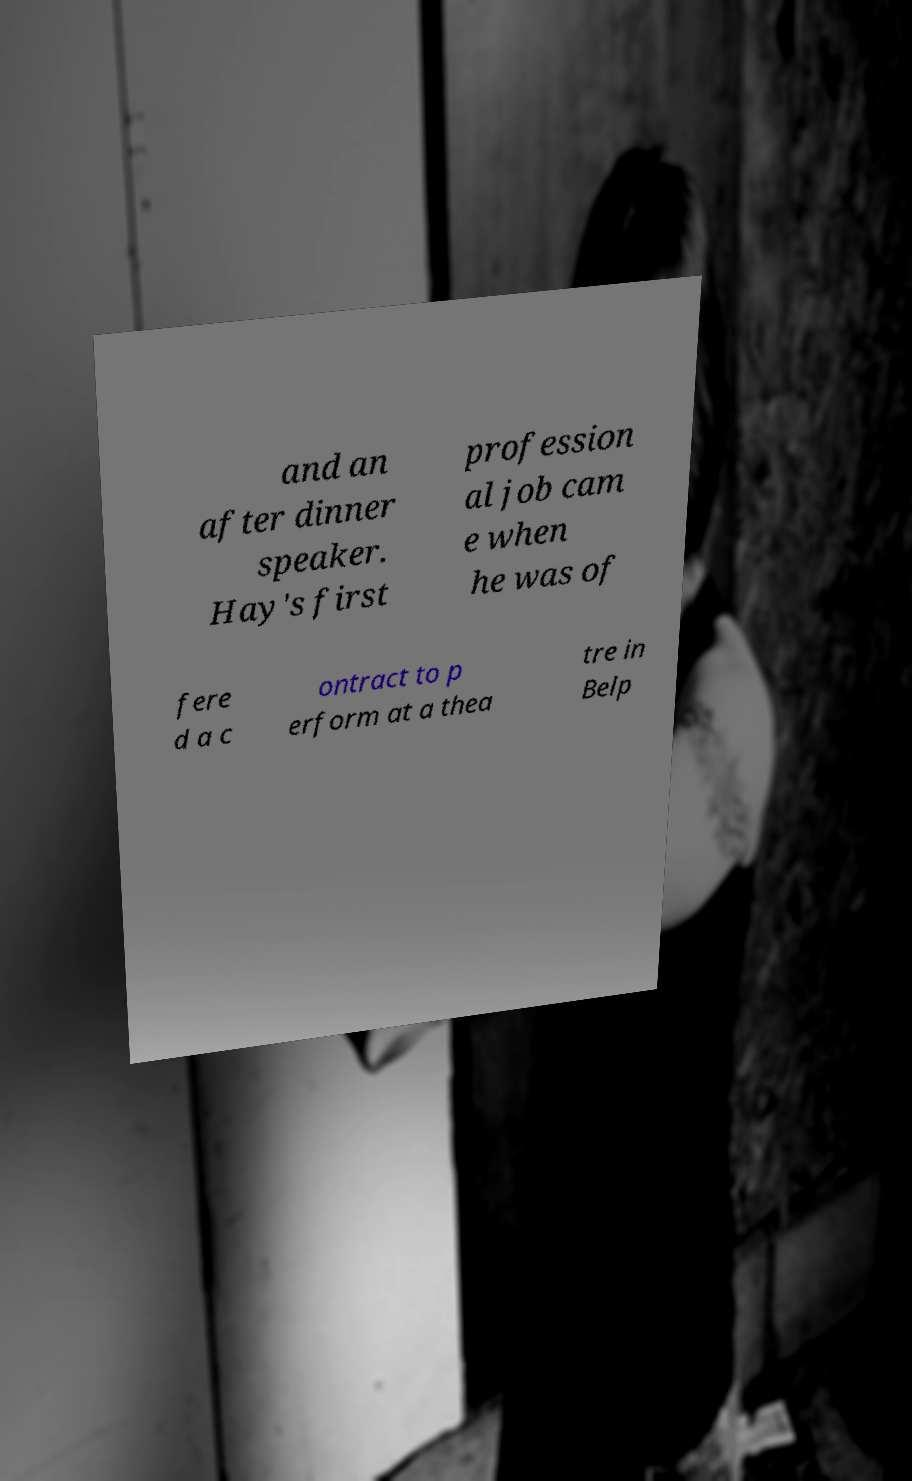For documentation purposes, I need the text within this image transcribed. Could you provide that? and an after dinner speaker. Hay's first profession al job cam e when he was of fere d a c ontract to p erform at a thea tre in Belp 